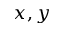<formula> <loc_0><loc_0><loc_500><loc_500>x , y</formula> 